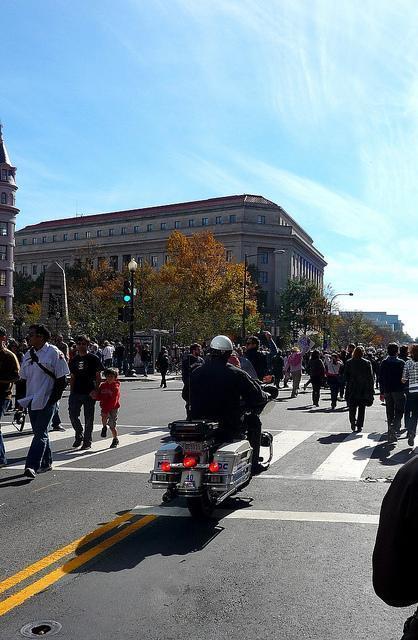How many people are in the picture?
Give a very brief answer. 5. How many giraffes are looking away from the camera?
Give a very brief answer. 0. 